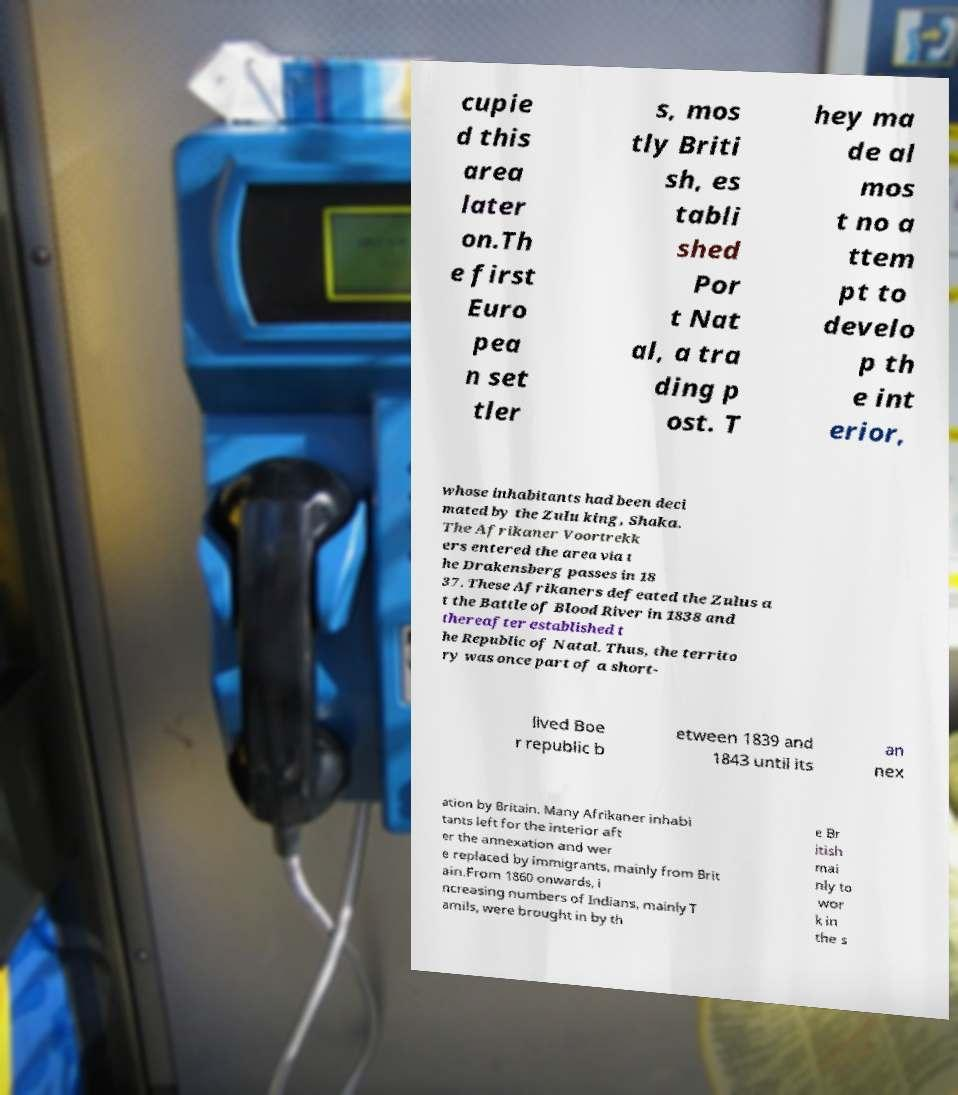Can you read and provide the text displayed in the image?This photo seems to have some interesting text. Can you extract and type it out for me? cupie d this area later on.Th e first Euro pea n set tler s, mos tly Briti sh, es tabli shed Por t Nat al, a tra ding p ost. T hey ma de al mos t no a ttem pt to develo p th e int erior, whose inhabitants had been deci mated by the Zulu king, Shaka. The Afrikaner Voortrekk ers entered the area via t he Drakensberg passes in 18 37. These Afrikaners defeated the Zulus a t the Battle of Blood River in 1838 and thereafter established t he Republic of Natal. Thus, the territo ry was once part of a short- lived Boe r republic b etween 1839 and 1843 until its an nex ation by Britain. Many Afrikaner inhabi tants left for the interior aft er the annexation and wer e replaced by immigrants, mainly from Brit ain.From 1860 onwards, i ncreasing numbers of Indians, mainly T amils, were brought in by th e Br itish mai nly to wor k in the s 